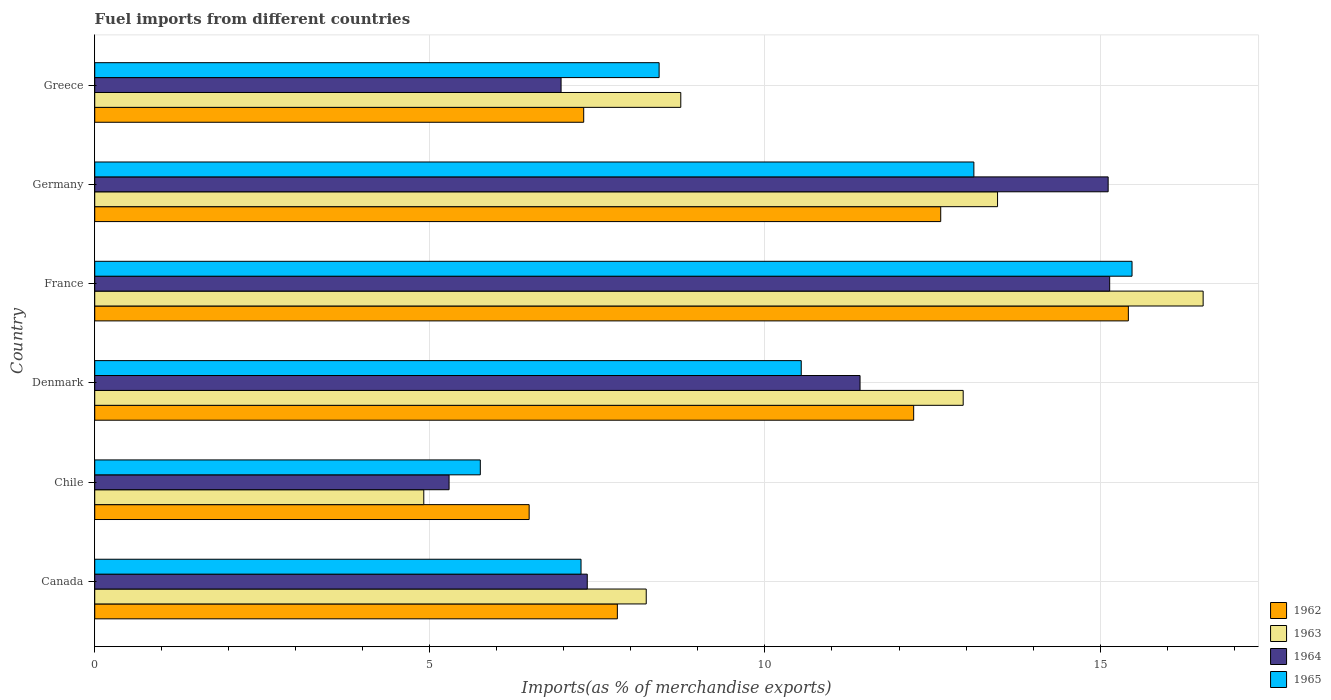How many different coloured bars are there?
Ensure brevity in your answer.  4. How many groups of bars are there?
Offer a terse response. 6. Are the number of bars per tick equal to the number of legend labels?
Your answer should be very brief. Yes. How many bars are there on the 5th tick from the bottom?
Provide a succinct answer. 4. What is the percentage of imports to different countries in 1963 in Denmark?
Ensure brevity in your answer.  12.96. Across all countries, what is the maximum percentage of imports to different countries in 1964?
Provide a succinct answer. 15.14. Across all countries, what is the minimum percentage of imports to different countries in 1963?
Your response must be concise. 4.91. In which country was the percentage of imports to different countries in 1964 maximum?
Provide a succinct answer. France. What is the total percentage of imports to different countries in 1962 in the graph?
Keep it short and to the point. 61.84. What is the difference between the percentage of imports to different countries in 1965 in Chile and that in Germany?
Your answer should be very brief. -7.36. What is the difference between the percentage of imports to different countries in 1964 in Greece and the percentage of imports to different countries in 1965 in France?
Keep it short and to the point. -8.52. What is the average percentage of imports to different countries in 1962 per country?
Provide a short and direct response. 10.31. What is the difference between the percentage of imports to different countries in 1965 and percentage of imports to different countries in 1962 in France?
Provide a succinct answer. 0.05. In how many countries, is the percentage of imports to different countries in 1962 greater than 3 %?
Make the answer very short. 6. What is the ratio of the percentage of imports to different countries in 1965 in Canada to that in Greece?
Ensure brevity in your answer.  0.86. Is the difference between the percentage of imports to different countries in 1965 in Chile and France greater than the difference between the percentage of imports to different countries in 1962 in Chile and France?
Provide a succinct answer. No. What is the difference between the highest and the second highest percentage of imports to different countries in 1962?
Keep it short and to the point. 2.8. What is the difference between the highest and the lowest percentage of imports to different countries in 1965?
Offer a terse response. 9.72. In how many countries, is the percentage of imports to different countries in 1963 greater than the average percentage of imports to different countries in 1963 taken over all countries?
Your answer should be very brief. 3. Is the sum of the percentage of imports to different countries in 1964 in Denmark and Greece greater than the maximum percentage of imports to different countries in 1962 across all countries?
Provide a succinct answer. Yes. Is it the case that in every country, the sum of the percentage of imports to different countries in 1962 and percentage of imports to different countries in 1964 is greater than the sum of percentage of imports to different countries in 1965 and percentage of imports to different countries in 1963?
Your answer should be compact. No. How many countries are there in the graph?
Give a very brief answer. 6. What is the difference between two consecutive major ticks on the X-axis?
Offer a terse response. 5. Are the values on the major ticks of X-axis written in scientific E-notation?
Provide a short and direct response. No. Does the graph contain grids?
Ensure brevity in your answer.  Yes. What is the title of the graph?
Ensure brevity in your answer.  Fuel imports from different countries. Does "1970" appear as one of the legend labels in the graph?
Provide a succinct answer. No. What is the label or title of the X-axis?
Give a very brief answer. Imports(as % of merchandise exports). What is the label or title of the Y-axis?
Your answer should be compact. Country. What is the Imports(as % of merchandise exports) in 1962 in Canada?
Provide a succinct answer. 7.8. What is the Imports(as % of merchandise exports) in 1963 in Canada?
Offer a terse response. 8.23. What is the Imports(as % of merchandise exports) of 1964 in Canada?
Your response must be concise. 7.35. What is the Imports(as % of merchandise exports) of 1965 in Canada?
Offer a terse response. 7.26. What is the Imports(as % of merchandise exports) of 1962 in Chile?
Keep it short and to the point. 6.48. What is the Imports(as % of merchandise exports) in 1963 in Chile?
Make the answer very short. 4.91. What is the Imports(as % of merchandise exports) in 1964 in Chile?
Provide a short and direct response. 5.29. What is the Imports(as % of merchandise exports) in 1965 in Chile?
Your answer should be very brief. 5.75. What is the Imports(as % of merchandise exports) of 1962 in Denmark?
Give a very brief answer. 12.22. What is the Imports(as % of merchandise exports) of 1963 in Denmark?
Provide a short and direct response. 12.96. What is the Imports(as % of merchandise exports) in 1964 in Denmark?
Your response must be concise. 11.42. What is the Imports(as % of merchandise exports) in 1965 in Denmark?
Keep it short and to the point. 10.54. What is the Imports(as % of merchandise exports) in 1962 in France?
Your answer should be compact. 15.42. What is the Imports(as % of merchandise exports) in 1963 in France?
Give a very brief answer. 16.54. What is the Imports(as % of merchandise exports) in 1964 in France?
Your answer should be compact. 15.14. What is the Imports(as % of merchandise exports) of 1965 in France?
Ensure brevity in your answer.  15.48. What is the Imports(as % of merchandise exports) of 1962 in Germany?
Your answer should be compact. 12.62. What is the Imports(as % of merchandise exports) of 1963 in Germany?
Offer a very short reply. 13.47. What is the Imports(as % of merchandise exports) in 1964 in Germany?
Make the answer very short. 15.12. What is the Imports(as % of merchandise exports) of 1965 in Germany?
Provide a succinct answer. 13.12. What is the Imports(as % of merchandise exports) of 1962 in Greece?
Your response must be concise. 7.3. What is the Imports(as % of merchandise exports) in 1963 in Greece?
Provide a short and direct response. 8.74. What is the Imports(as % of merchandise exports) of 1964 in Greece?
Offer a terse response. 6.96. What is the Imports(as % of merchandise exports) of 1965 in Greece?
Provide a short and direct response. 8.42. Across all countries, what is the maximum Imports(as % of merchandise exports) of 1962?
Provide a succinct answer. 15.42. Across all countries, what is the maximum Imports(as % of merchandise exports) in 1963?
Offer a very short reply. 16.54. Across all countries, what is the maximum Imports(as % of merchandise exports) of 1964?
Offer a very short reply. 15.14. Across all countries, what is the maximum Imports(as % of merchandise exports) of 1965?
Ensure brevity in your answer.  15.48. Across all countries, what is the minimum Imports(as % of merchandise exports) in 1962?
Offer a terse response. 6.48. Across all countries, what is the minimum Imports(as % of merchandise exports) in 1963?
Your answer should be very brief. 4.91. Across all countries, what is the minimum Imports(as % of merchandise exports) in 1964?
Provide a succinct answer. 5.29. Across all countries, what is the minimum Imports(as % of merchandise exports) of 1965?
Ensure brevity in your answer.  5.75. What is the total Imports(as % of merchandise exports) in 1962 in the graph?
Your answer should be very brief. 61.84. What is the total Imports(as % of merchandise exports) in 1963 in the graph?
Give a very brief answer. 64.85. What is the total Imports(as % of merchandise exports) in 1964 in the graph?
Keep it short and to the point. 61.28. What is the total Imports(as % of merchandise exports) of 1965 in the graph?
Your answer should be compact. 60.57. What is the difference between the Imports(as % of merchandise exports) of 1962 in Canada and that in Chile?
Ensure brevity in your answer.  1.32. What is the difference between the Imports(as % of merchandise exports) in 1963 in Canada and that in Chile?
Your response must be concise. 3.32. What is the difference between the Imports(as % of merchandise exports) in 1964 in Canada and that in Chile?
Offer a very short reply. 2.06. What is the difference between the Imports(as % of merchandise exports) of 1965 in Canada and that in Chile?
Give a very brief answer. 1.5. What is the difference between the Imports(as % of merchandise exports) of 1962 in Canada and that in Denmark?
Your answer should be very brief. -4.42. What is the difference between the Imports(as % of merchandise exports) in 1963 in Canada and that in Denmark?
Offer a terse response. -4.73. What is the difference between the Imports(as % of merchandise exports) in 1964 in Canada and that in Denmark?
Offer a terse response. -4.07. What is the difference between the Imports(as % of merchandise exports) of 1965 in Canada and that in Denmark?
Provide a short and direct response. -3.29. What is the difference between the Imports(as % of merchandise exports) in 1962 in Canada and that in France?
Offer a very short reply. -7.62. What is the difference between the Imports(as % of merchandise exports) of 1963 in Canada and that in France?
Give a very brief answer. -8.31. What is the difference between the Imports(as % of merchandise exports) of 1964 in Canada and that in France?
Make the answer very short. -7.79. What is the difference between the Imports(as % of merchandise exports) of 1965 in Canada and that in France?
Your answer should be very brief. -8.22. What is the difference between the Imports(as % of merchandise exports) of 1962 in Canada and that in Germany?
Make the answer very short. -4.82. What is the difference between the Imports(as % of merchandise exports) in 1963 in Canada and that in Germany?
Provide a succinct answer. -5.24. What is the difference between the Imports(as % of merchandise exports) in 1964 in Canada and that in Germany?
Offer a very short reply. -7.77. What is the difference between the Imports(as % of merchandise exports) in 1965 in Canada and that in Germany?
Offer a very short reply. -5.86. What is the difference between the Imports(as % of merchandise exports) of 1962 in Canada and that in Greece?
Offer a very short reply. 0.5. What is the difference between the Imports(as % of merchandise exports) of 1963 in Canada and that in Greece?
Give a very brief answer. -0.52. What is the difference between the Imports(as % of merchandise exports) in 1964 in Canada and that in Greece?
Give a very brief answer. 0.39. What is the difference between the Imports(as % of merchandise exports) in 1965 in Canada and that in Greece?
Offer a very short reply. -1.17. What is the difference between the Imports(as % of merchandise exports) in 1962 in Chile and that in Denmark?
Provide a succinct answer. -5.74. What is the difference between the Imports(as % of merchandise exports) in 1963 in Chile and that in Denmark?
Ensure brevity in your answer.  -8.05. What is the difference between the Imports(as % of merchandise exports) of 1964 in Chile and that in Denmark?
Offer a very short reply. -6.13. What is the difference between the Imports(as % of merchandise exports) of 1965 in Chile and that in Denmark?
Your answer should be very brief. -4.79. What is the difference between the Imports(as % of merchandise exports) of 1962 in Chile and that in France?
Provide a succinct answer. -8.94. What is the difference between the Imports(as % of merchandise exports) in 1963 in Chile and that in France?
Keep it short and to the point. -11.63. What is the difference between the Imports(as % of merchandise exports) in 1964 in Chile and that in France?
Ensure brevity in your answer.  -9.86. What is the difference between the Imports(as % of merchandise exports) in 1965 in Chile and that in France?
Keep it short and to the point. -9.72. What is the difference between the Imports(as % of merchandise exports) of 1962 in Chile and that in Germany?
Your response must be concise. -6.14. What is the difference between the Imports(as % of merchandise exports) of 1963 in Chile and that in Germany?
Make the answer very short. -8.56. What is the difference between the Imports(as % of merchandise exports) of 1964 in Chile and that in Germany?
Keep it short and to the point. -9.83. What is the difference between the Imports(as % of merchandise exports) in 1965 in Chile and that in Germany?
Offer a terse response. -7.36. What is the difference between the Imports(as % of merchandise exports) in 1962 in Chile and that in Greece?
Give a very brief answer. -0.81. What is the difference between the Imports(as % of merchandise exports) of 1963 in Chile and that in Greece?
Your answer should be very brief. -3.83. What is the difference between the Imports(as % of merchandise exports) of 1964 in Chile and that in Greece?
Give a very brief answer. -1.67. What is the difference between the Imports(as % of merchandise exports) of 1965 in Chile and that in Greece?
Your response must be concise. -2.67. What is the difference between the Imports(as % of merchandise exports) of 1962 in Denmark and that in France?
Offer a very short reply. -3.2. What is the difference between the Imports(as % of merchandise exports) in 1963 in Denmark and that in France?
Your response must be concise. -3.58. What is the difference between the Imports(as % of merchandise exports) in 1964 in Denmark and that in France?
Your response must be concise. -3.72. What is the difference between the Imports(as % of merchandise exports) of 1965 in Denmark and that in France?
Your answer should be compact. -4.94. What is the difference between the Imports(as % of merchandise exports) of 1962 in Denmark and that in Germany?
Your answer should be compact. -0.4. What is the difference between the Imports(as % of merchandise exports) in 1963 in Denmark and that in Germany?
Offer a terse response. -0.51. What is the difference between the Imports(as % of merchandise exports) in 1964 in Denmark and that in Germany?
Offer a very short reply. -3.7. What is the difference between the Imports(as % of merchandise exports) in 1965 in Denmark and that in Germany?
Offer a terse response. -2.58. What is the difference between the Imports(as % of merchandise exports) in 1962 in Denmark and that in Greece?
Give a very brief answer. 4.92. What is the difference between the Imports(as % of merchandise exports) of 1963 in Denmark and that in Greece?
Ensure brevity in your answer.  4.21. What is the difference between the Imports(as % of merchandise exports) in 1964 in Denmark and that in Greece?
Provide a succinct answer. 4.46. What is the difference between the Imports(as % of merchandise exports) in 1965 in Denmark and that in Greece?
Make the answer very short. 2.12. What is the difference between the Imports(as % of merchandise exports) in 1962 in France and that in Germany?
Your answer should be compact. 2.8. What is the difference between the Imports(as % of merchandise exports) of 1963 in France and that in Germany?
Your answer should be very brief. 3.07. What is the difference between the Imports(as % of merchandise exports) of 1964 in France and that in Germany?
Your answer should be compact. 0.02. What is the difference between the Imports(as % of merchandise exports) of 1965 in France and that in Germany?
Ensure brevity in your answer.  2.36. What is the difference between the Imports(as % of merchandise exports) of 1962 in France and that in Greece?
Give a very brief answer. 8.13. What is the difference between the Imports(as % of merchandise exports) in 1963 in France and that in Greece?
Offer a very short reply. 7.79. What is the difference between the Imports(as % of merchandise exports) in 1964 in France and that in Greece?
Make the answer very short. 8.19. What is the difference between the Imports(as % of merchandise exports) of 1965 in France and that in Greece?
Provide a short and direct response. 7.06. What is the difference between the Imports(as % of merchandise exports) of 1962 in Germany and that in Greece?
Make the answer very short. 5.33. What is the difference between the Imports(as % of merchandise exports) in 1963 in Germany and that in Greece?
Give a very brief answer. 4.73. What is the difference between the Imports(as % of merchandise exports) in 1964 in Germany and that in Greece?
Give a very brief answer. 8.16. What is the difference between the Imports(as % of merchandise exports) of 1965 in Germany and that in Greece?
Your answer should be compact. 4.7. What is the difference between the Imports(as % of merchandise exports) of 1962 in Canada and the Imports(as % of merchandise exports) of 1963 in Chile?
Give a very brief answer. 2.89. What is the difference between the Imports(as % of merchandise exports) of 1962 in Canada and the Imports(as % of merchandise exports) of 1964 in Chile?
Make the answer very short. 2.51. What is the difference between the Imports(as % of merchandise exports) in 1962 in Canada and the Imports(as % of merchandise exports) in 1965 in Chile?
Your answer should be compact. 2.04. What is the difference between the Imports(as % of merchandise exports) of 1963 in Canada and the Imports(as % of merchandise exports) of 1964 in Chile?
Give a very brief answer. 2.94. What is the difference between the Imports(as % of merchandise exports) of 1963 in Canada and the Imports(as % of merchandise exports) of 1965 in Chile?
Give a very brief answer. 2.48. What is the difference between the Imports(as % of merchandise exports) in 1964 in Canada and the Imports(as % of merchandise exports) in 1965 in Chile?
Your response must be concise. 1.6. What is the difference between the Imports(as % of merchandise exports) of 1962 in Canada and the Imports(as % of merchandise exports) of 1963 in Denmark?
Provide a short and direct response. -5.16. What is the difference between the Imports(as % of merchandise exports) in 1962 in Canada and the Imports(as % of merchandise exports) in 1964 in Denmark?
Make the answer very short. -3.62. What is the difference between the Imports(as % of merchandise exports) in 1962 in Canada and the Imports(as % of merchandise exports) in 1965 in Denmark?
Make the answer very short. -2.74. What is the difference between the Imports(as % of merchandise exports) of 1963 in Canada and the Imports(as % of merchandise exports) of 1964 in Denmark?
Offer a terse response. -3.19. What is the difference between the Imports(as % of merchandise exports) in 1963 in Canada and the Imports(as % of merchandise exports) in 1965 in Denmark?
Your response must be concise. -2.31. What is the difference between the Imports(as % of merchandise exports) of 1964 in Canada and the Imports(as % of merchandise exports) of 1965 in Denmark?
Ensure brevity in your answer.  -3.19. What is the difference between the Imports(as % of merchandise exports) of 1962 in Canada and the Imports(as % of merchandise exports) of 1963 in France?
Give a very brief answer. -8.74. What is the difference between the Imports(as % of merchandise exports) of 1962 in Canada and the Imports(as % of merchandise exports) of 1964 in France?
Give a very brief answer. -7.35. What is the difference between the Imports(as % of merchandise exports) in 1962 in Canada and the Imports(as % of merchandise exports) in 1965 in France?
Your answer should be very brief. -7.68. What is the difference between the Imports(as % of merchandise exports) in 1963 in Canada and the Imports(as % of merchandise exports) in 1964 in France?
Keep it short and to the point. -6.91. What is the difference between the Imports(as % of merchandise exports) of 1963 in Canada and the Imports(as % of merchandise exports) of 1965 in France?
Provide a succinct answer. -7.25. What is the difference between the Imports(as % of merchandise exports) of 1964 in Canada and the Imports(as % of merchandise exports) of 1965 in France?
Provide a succinct answer. -8.13. What is the difference between the Imports(as % of merchandise exports) in 1962 in Canada and the Imports(as % of merchandise exports) in 1963 in Germany?
Offer a terse response. -5.67. What is the difference between the Imports(as % of merchandise exports) in 1962 in Canada and the Imports(as % of merchandise exports) in 1964 in Germany?
Your response must be concise. -7.32. What is the difference between the Imports(as % of merchandise exports) of 1962 in Canada and the Imports(as % of merchandise exports) of 1965 in Germany?
Your response must be concise. -5.32. What is the difference between the Imports(as % of merchandise exports) of 1963 in Canada and the Imports(as % of merchandise exports) of 1964 in Germany?
Your response must be concise. -6.89. What is the difference between the Imports(as % of merchandise exports) in 1963 in Canada and the Imports(as % of merchandise exports) in 1965 in Germany?
Your response must be concise. -4.89. What is the difference between the Imports(as % of merchandise exports) in 1964 in Canada and the Imports(as % of merchandise exports) in 1965 in Germany?
Your answer should be very brief. -5.77. What is the difference between the Imports(as % of merchandise exports) in 1962 in Canada and the Imports(as % of merchandise exports) in 1963 in Greece?
Keep it short and to the point. -0.95. What is the difference between the Imports(as % of merchandise exports) of 1962 in Canada and the Imports(as % of merchandise exports) of 1964 in Greece?
Provide a short and direct response. 0.84. What is the difference between the Imports(as % of merchandise exports) of 1962 in Canada and the Imports(as % of merchandise exports) of 1965 in Greece?
Your answer should be very brief. -0.62. What is the difference between the Imports(as % of merchandise exports) in 1963 in Canada and the Imports(as % of merchandise exports) in 1964 in Greece?
Keep it short and to the point. 1.27. What is the difference between the Imports(as % of merchandise exports) of 1963 in Canada and the Imports(as % of merchandise exports) of 1965 in Greece?
Provide a succinct answer. -0.19. What is the difference between the Imports(as % of merchandise exports) in 1964 in Canada and the Imports(as % of merchandise exports) in 1965 in Greece?
Provide a short and direct response. -1.07. What is the difference between the Imports(as % of merchandise exports) of 1962 in Chile and the Imports(as % of merchandise exports) of 1963 in Denmark?
Your answer should be very brief. -6.48. What is the difference between the Imports(as % of merchandise exports) in 1962 in Chile and the Imports(as % of merchandise exports) in 1964 in Denmark?
Offer a terse response. -4.94. What is the difference between the Imports(as % of merchandise exports) of 1962 in Chile and the Imports(as % of merchandise exports) of 1965 in Denmark?
Your response must be concise. -4.06. What is the difference between the Imports(as % of merchandise exports) in 1963 in Chile and the Imports(as % of merchandise exports) in 1964 in Denmark?
Your answer should be compact. -6.51. What is the difference between the Imports(as % of merchandise exports) in 1963 in Chile and the Imports(as % of merchandise exports) in 1965 in Denmark?
Your answer should be very brief. -5.63. What is the difference between the Imports(as % of merchandise exports) of 1964 in Chile and the Imports(as % of merchandise exports) of 1965 in Denmark?
Offer a very short reply. -5.25. What is the difference between the Imports(as % of merchandise exports) in 1962 in Chile and the Imports(as % of merchandise exports) in 1963 in France?
Keep it short and to the point. -10.06. What is the difference between the Imports(as % of merchandise exports) in 1962 in Chile and the Imports(as % of merchandise exports) in 1964 in France?
Your response must be concise. -8.66. What is the difference between the Imports(as % of merchandise exports) of 1962 in Chile and the Imports(as % of merchandise exports) of 1965 in France?
Your answer should be very brief. -9. What is the difference between the Imports(as % of merchandise exports) of 1963 in Chile and the Imports(as % of merchandise exports) of 1964 in France?
Ensure brevity in your answer.  -10.23. What is the difference between the Imports(as % of merchandise exports) in 1963 in Chile and the Imports(as % of merchandise exports) in 1965 in France?
Give a very brief answer. -10.57. What is the difference between the Imports(as % of merchandise exports) in 1964 in Chile and the Imports(as % of merchandise exports) in 1965 in France?
Your answer should be compact. -10.19. What is the difference between the Imports(as % of merchandise exports) of 1962 in Chile and the Imports(as % of merchandise exports) of 1963 in Germany?
Offer a terse response. -6.99. What is the difference between the Imports(as % of merchandise exports) in 1962 in Chile and the Imports(as % of merchandise exports) in 1964 in Germany?
Offer a very short reply. -8.64. What is the difference between the Imports(as % of merchandise exports) of 1962 in Chile and the Imports(as % of merchandise exports) of 1965 in Germany?
Provide a short and direct response. -6.64. What is the difference between the Imports(as % of merchandise exports) in 1963 in Chile and the Imports(as % of merchandise exports) in 1964 in Germany?
Your answer should be compact. -10.21. What is the difference between the Imports(as % of merchandise exports) in 1963 in Chile and the Imports(as % of merchandise exports) in 1965 in Germany?
Ensure brevity in your answer.  -8.21. What is the difference between the Imports(as % of merchandise exports) in 1964 in Chile and the Imports(as % of merchandise exports) in 1965 in Germany?
Your response must be concise. -7.83. What is the difference between the Imports(as % of merchandise exports) in 1962 in Chile and the Imports(as % of merchandise exports) in 1963 in Greece?
Give a very brief answer. -2.26. What is the difference between the Imports(as % of merchandise exports) of 1962 in Chile and the Imports(as % of merchandise exports) of 1964 in Greece?
Keep it short and to the point. -0.48. What is the difference between the Imports(as % of merchandise exports) of 1962 in Chile and the Imports(as % of merchandise exports) of 1965 in Greece?
Keep it short and to the point. -1.94. What is the difference between the Imports(as % of merchandise exports) of 1963 in Chile and the Imports(as % of merchandise exports) of 1964 in Greece?
Your answer should be compact. -2.05. What is the difference between the Imports(as % of merchandise exports) in 1963 in Chile and the Imports(as % of merchandise exports) in 1965 in Greece?
Provide a succinct answer. -3.51. What is the difference between the Imports(as % of merchandise exports) of 1964 in Chile and the Imports(as % of merchandise exports) of 1965 in Greece?
Your answer should be compact. -3.13. What is the difference between the Imports(as % of merchandise exports) of 1962 in Denmark and the Imports(as % of merchandise exports) of 1963 in France?
Your answer should be very brief. -4.32. What is the difference between the Imports(as % of merchandise exports) in 1962 in Denmark and the Imports(as % of merchandise exports) in 1964 in France?
Make the answer very short. -2.92. What is the difference between the Imports(as % of merchandise exports) in 1962 in Denmark and the Imports(as % of merchandise exports) in 1965 in France?
Your response must be concise. -3.26. What is the difference between the Imports(as % of merchandise exports) of 1963 in Denmark and the Imports(as % of merchandise exports) of 1964 in France?
Provide a short and direct response. -2.19. What is the difference between the Imports(as % of merchandise exports) of 1963 in Denmark and the Imports(as % of merchandise exports) of 1965 in France?
Your response must be concise. -2.52. What is the difference between the Imports(as % of merchandise exports) in 1964 in Denmark and the Imports(as % of merchandise exports) in 1965 in France?
Keep it short and to the point. -4.06. What is the difference between the Imports(as % of merchandise exports) of 1962 in Denmark and the Imports(as % of merchandise exports) of 1963 in Germany?
Your answer should be compact. -1.25. What is the difference between the Imports(as % of merchandise exports) of 1962 in Denmark and the Imports(as % of merchandise exports) of 1964 in Germany?
Give a very brief answer. -2.9. What is the difference between the Imports(as % of merchandise exports) of 1962 in Denmark and the Imports(as % of merchandise exports) of 1965 in Germany?
Provide a succinct answer. -0.9. What is the difference between the Imports(as % of merchandise exports) in 1963 in Denmark and the Imports(as % of merchandise exports) in 1964 in Germany?
Give a very brief answer. -2.16. What is the difference between the Imports(as % of merchandise exports) of 1963 in Denmark and the Imports(as % of merchandise exports) of 1965 in Germany?
Offer a terse response. -0.16. What is the difference between the Imports(as % of merchandise exports) of 1964 in Denmark and the Imports(as % of merchandise exports) of 1965 in Germany?
Offer a very short reply. -1.7. What is the difference between the Imports(as % of merchandise exports) of 1962 in Denmark and the Imports(as % of merchandise exports) of 1963 in Greece?
Make the answer very short. 3.48. What is the difference between the Imports(as % of merchandise exports) of 1962 in Denmark and the Imports(as % of merchandise exports) of 1964 in Greece?
Your answer should be very brief. 5.26. What is the difference between the Imports(as % of merchandise exports) in 1962 in Denmark and the Imports(as % of merchandise exports) in 1965 in Greece?
Your answer should be compact. 3.8. What is the difference between the Imports(as % of merchandise exports) in 1963 in Denmark and the Imports(as % of merchandise exports) in 1964 in Greece?
Make the answer very short. 6. What is the difference between the Imports(as % of merchandise exports) of 1963 in Denmark and the Imports(as % of merchandise exports) of 1965 in Greece?
Ensure brevity in your answer.  4.54. What is the difference between the Imports(as % of merchandise exports) in 1964 in Denmark and the Imports(as % of merchandise exports) in 1965 in Greece?
Your response must be concise. 3. What is the difference between the Imports(as % of merchandise exports) in 1962 in France and the Imports(as % of merchandise exports) in 1963 in Germany?
Ensure brevity in your answer.  1.95. What is the difference between the Imports(as % of merchandise exports) of 1962 in France and the Imports(as % of merchandise exports) of 1964 in Germany?
Keep it short and to the point. 0.3. What is the difference between the Imports(as % of merchandise exports) of 1962 in France and the Imports(as % of merchandise exports) of 1965 in Germany?
Provide a succinct answer. 2.31. What is the difference between the Imports(as % of merchandise exports) in 1963 in France and the Imports(as % of merchandise exports) in 1964 in Germany?
Your answer should be compact. 1.42. What is the difference between the Imports(as % of merchandise exports) in 1963 in France and the Imports(as % of merchandise exports) in 1965 in Germany?
Offer a terse response. 3.42. What is the difference between the Imports(as % of merchandise exports) of 1964 in France and the Imports(as % of merchandise exports) of 1965 in Germany?
Make the answer very short. 2.03. What is the difference between the Imports(as % of merchandise exports) in 1962 in France and the Imports(as % of merchandise exports) in 1963 in Greece?
Offer a very short reply. 6.68. What is the difference between the Imports(as % of merchandise exports) of 1962 in France and the Imports(as % of merchandise exports) of 1964 in Greece?
Provide a short and direct response. 8.46. What is the difference between the Imports(as % of merchandise exports) of 1962 in France and the Imports(as % of merchandise exports) of 1965 in Greece?
Make the answer very short. 7. What is the difference between the Imports(as % of merchandise exports) in 1963 in France and the Imports(as % of merchandise exports) in 1964 in Greece?
Offer a very short reply. 9.58. What is the difference between the Imports(as % of merchandise exports) in 1963 in France and the Imports(as % of merchandise exports) in 1965 in Greece?
Give a very brief answer. 8.12. What is the difference between the Imports(as % of merchandise exports) of 1964 in France and the Imports(as % of merchandise exports) of 1965 in Greece?
Ensure brevity in your answer.  6.72. What is the difference between the Imports(as % of merchandise exports) in 1962 in Germany and the Imports(as % of merchandise exports) in 1963 in Greece?
Give a very brief answer. 3.88. What is the difference between the Imports(as % of merchandise exports) of 1962 in Germany and the Imports(as % of merchandise exports) of 1964 in Greece?
Provide a short and direct response. 5.66. What is the difference between the Imports(as % of merchandise exports) of 1962 in Germany and the Imports(as % of merchandise exports) of 1965 in Greece?
Your answer should be very brief. 4.2. What is the difference between the Imports(as % of merchandise exports) in 1963 in Germany and the Imports(as % of merchandise exports) in 1964 in Greece?
Your answer should be compact. 6.51. What is the difference between the Imports(as % of merchandise exports) of 1963 in Germany and the Imports(as % of merchandise exports) of 1965 in Greece?
Offer a terse response. 5.05. What is the difference between the Imports(as % of merchandise exports) in 1964 in Germany and the Imports(as % of merchandise exports) in 1965 in Greece?
Provide a short and direct response. 6.7. What is the average Imports(as % of merchandise exports) in 1962 per country?
Ensure brevity in your answer.  10.31. What is the average Imports(as % of merchandise exports) in 1963 per country?
Your answer should be compact. 10.81. What is the average Imports(as % of merchandise exports) in 1964 per country?
Provide a succinct answer. 10.21. What is the average Imports(as % of merchandise exports) in 1965 per country?
Provide a short and direct response. 10.09. What is the difference between the Imports(as % of merchandise exports) of 1962 and Imports(as % of merchandise exports) of 1963 in Canada?
Offer a very short reply. -0.43. What is the difference between the Imports(as % of merchandise exports) of 1962 and Imports(as % of merchandise exports) of 1964 in Canada?
Your response must be concise. 0.45. What is the difference between the Imports(as % of merchandise exports) in 1962 and Imports(as % of merchandise exports) in 1965 in Canada?
Provide a short and direct response. 0.54. What is the difference between the Imports(as % of merchandise exports) in 1963 and Imports(as % of merchandise exports) in 1964 in Canada?
Offer a very short reply. 0.88. What is the difference between the Imports(as % of merchandise exports) in 1963 and Imports(as % of merchandise exports) in 1965 in Canada?
Your answer should be compact. 0.97. What is the difference between the Imports(as % of merchandise exports) of 1964 and Imports(as % of merchandise exports) of 1965 in Canada?
Make the answer very short. 0.09. What is the difference between the Imports(as % of merchandise exports) in 1962 and Imports(as % of merchandise exports) in 1963 in Chile?
Your response must be concise. 1.57. What is the difference between the Imports(as % of merchandise exports) in 1962 and Imports(as % of merchandise exports) in 1964 in Chile?
Make the answer very short. 1.19. What is the difference between the Imports(as % of merchandise exports) of 1962 and Imports(as % of merchandise exports) of 1965 in Chile?
Provide a succinct answer. 0.73. What is the difference between the Imports(as % of merchandise exports) in 1963 and Imports(as % of merchandise exports) in 1964 in Chile?
Your answer should be very brief. -0.38. What is the difference between the Imports(as % of merchandise exports) of 1963 and Imports(as % of merchandise exports) of 1965 in Chile?
Your answer should be compact. -0.84. What is the difference between the Imports(as % of merchandise exports) of 1964 and Imports(as % of merchandise exports) of 1965 in Chile?
Give a very brief answer. -0.47. What is the difference between the Imports(as % of merchandise exports) in 1962 and Imports(as % of merchandise exports) in 1963 in Denmark?
Offer a terse response. -0.74. What is the difference between the Imports(as % of merchandise exports) in 1962 and Imports(as % of merchandise exports) in 1964 in Denmark?
Keep it short and to the point. 0.8. What is the difference between the Imports(as % of merchandise exports) in 1962 and Imports(as % of merchandise exports) in 1965 in Denmark?
Provide a succinct answer. 1.68. What is the difference between the Imports(as % of merchandise exports) in 1963 and Imports(as % of merchandise exports) in 1964 in Denmark?
Make the answer very short. 1.54. What is the difference between the Imports(as % of merchandise exports) in 1963 and Imports(as % of merchandise exports) in 1965 in Denmark?
Provide a succinct answer. 2.42. What is the difference between the Imports(as % of merchandise exports) of 1964 and Imports(as % of merchandise exports) of 1965 in Denmark?
Your answer should be compact. 0.88. What is the difference between the Imports(as % of merchandise exports) in 1962 and Imports(as % of merchandise exports) in 1963 in France?
Give a very brief answer. -1.12. What is the difference between the Imports(as % of merchandise exports) in 1962 and Imports(as % of merchandise exports) in 1964 in France?
Keep it short and to the point. 0.28. What is the difference between the Imports(as % of merchandise exports) of 1962 and Imports(as % of merchandise exports) of 1965 in France?
Your answer should be compact. -0.05. What is the difference between the Imports(as % of merchandise exports) of 1963 and Imports(as % of merchandise exports) of 1964 in France?
Provide a short and direct response. 1.39. What is the difference between the Imports(as % of merchandise exports) of 1963 and Imports(as % of merchandise exports) of 1965 in France?
Ensure brevity in your answer.  1.06. What is the difference between the Imports(as % of merchandise exports) in 1964 and Imports(as % of merchandise exports) in 1965 in France?
Keep it short and to the point. -0.33. What is the difference between the Imports(as % of merchandise exports) in 1962 and Imports(as % of merchandise exports) in 1963 in Germany?
Offer a terse response. -0.85. What is the difference between the Imports(as % of merchandise exports) of 1962 and Imports(as % of merchandise exports) of 1964 in Germany?
Make the answer very short. -2.5. What is the difference between the Imports(as % of merchandise exports) in 1962 and Imports(as % of merchandise exports) in 1965 in Germany?
Your response must be concise. -0.49. What is the difference between the Imports(as % of merchandise exports) of 1963 and Imports(as % of merchandise exports) of 1964 in Germany?
Offer a terse response. -1.65. What is the difference between the Imports(as % of merchandise exports) of 1963 and Imports(as % of merchandise exports) of 1965 in Germany?
Give a very brief answer. 0.35. What is the difference between the Imports(as % of merchandise exports) of 1964 and Imports(as % of merchandise exports) of 1965 in Germany?
Keep it short and to the point. 2. What is the difference between the Imports(as % of merchandise exports) of 1962 and Imports(as % of merchandise exports) of 1963 in Greece?
Your response must be concise. -1.45. What is the difference between the Imports(as % of merchandise exports) of 1962 and Imports(as % of merchandise exports) of 1964 in Greece?
Your response must be concise. 0.34. What is the difference between the Imports(as % of merchandise exports) of 1962 and Imports(as % of merchandise exports) of 1965 in Greece?
Give a very brief answer. -1.13. What is the difference between the Imports(as % of merchandise exports) of 1963 and Imports(as % of merchandise exports) of 1964 in Greece?
Your response must be concise. 1.79. What is the difference between the Imports(as % of merchandise exports) in 1963 and Imports(as % of merchandise exports) in 1965 in Greece?
Your answer should be compact. 0.32. What is the difference between the Imports(as % of merchandise exports) in 1964 and Imports(as % of merchandise exports) in 1965 in Greece?
Offer a very short reply. -1.46. What is the ratio of the Imports(as % of merchandise exports) in 1962 in Canada to that in Chile?
Your response must be concise. 1.2. What is the ratio of the Imports(as % of merchandise exports) in 1963 in Canada to that in Chile?
Make the answer very short. 1.68. What is the ratio of the Imports(as % of merchandise exports) of 1964 in Canada to that in Chile?
Your response must be concise. 1.39. What is the ratio of the Imports(as % of merchandise exports) in 1965 in Canada to that in Chile?
Provide a succinct answer. 1.26. What is the ratio of the Imports(as % of merchandise exports) in 1962 in Canada to that in Denmark?
Offer a very short reply. 0.64. What is the ratio of the Imports(as % of merchandise exports) in 1963 in Canada to that in Denmark?
Your answer should be very brief. 0.64. What is the ratio of the Imports(as % of merchandise exports) in 1964 in Canada to that in Denmark?
Offer a terse response. 0.64. What is the ratio of the Imports(as % of merchandise exports) in 1965 in Canada to that in Denmark?
Your answer should be very brief. 0.69. What is the ratio of the Imports(as % of merchandise exports) in 1962 in Canada to that in France?
Give a very brief answer. 0.51. What is the ratio of the Imports(as % of merchandise exports) of 1963 in Canada to that in France?
Give a very brief answer. 0.5. What is the ratio of the Imports(as % of merchandise exports) in 1964 in Canada to that in France?
Offer a terse response. 0.49. What is the ratio of the Imports(as % of merchandise exports) in 1965 in Canada to that in France?
Offer a very short reply. 0.47. What is the ratio of the Imports(as % of merchandise exports) of 1962 in Canada to that in Germany?
Your answer should be very brief. 0.62. What is the ratio of the Imports(as % of merchandise exports) of 1963 in Canada to that in Germany?
Your response must be concise. 0.61. What is the ratio of the Imports(as % of merchandise exports) in 1964 in Canada to that in Germany?
Offer a very short reply. 0.49. What is the ratio of the Imports(as % of merchandise exports) of 1965 in Canada to that in Germany?
Provide a short and direct response. 0.55. What is the ratio of the Imports(as % of merchandise exports) of 1962 in Canada to that in Greece?
Offer a very short reply. 1.07. What is the ratio of the Imports(as % of merchandise exports) of 1963 in Canada to that in Greece?
Provide a succinct answer. 0.94. What is the ratio of the Imports(as % of merchandise exports) in 1964 in Canada to that in Greece?
Offer a terse response. 1.06. What is the ratio of the Imports(as % of merchandise exports) of 1965 in Canada to that in Greece?
Your answer should be very brief. 0.86. What is the ratio of the Imports(as % of merchandise exports) in 1962 in Chile to that in Denmark?
Offer a terse response. 0.53. What is the ratio of the Imports(as % of merchandise exports) of 1963 in Chile to that in Denmark?
Your response must be concise. 0.38. What is the ratio of the Imports(as % of merchandise exports) in 1964 in Chile to that in Denmark?
Provide a succinct answer. 0.46. What is the ratio of the Imports(as % of merchandise exports) in 1965 in Chile to that in Denmark?
Keep it short and to the point. 0.55. What is the ratio of the Imports(as % of merchandise exports) of 1962 in Chile to that in France?
Your answer should be compact. 0.42. What is the ratio of the Imports(as % of merchandise exports) in 1963 in Chile to that in France?
Offer a very short reply. 0.3. What is the ratio of the Imports(as % of merchandise exports) of 1964 in Chile to that in France?
Your response must be concise. 0.35. What is the ratio of the Imports(as % of merchandise exports) of 1965 in Chile to that in France?
Make the answer very short. 0.37. What is the ratio of the Imports(as % of merchandise exports) in 1962 in Chile to that in Germany?
Your answer should be compact. 0.51. What is the ratio of the Imports(as % of merchandise exports) of 1963 in Chile to that in Germany?
Provide a succinct answer. 0.36. What is the ratio of the Imports(as % of merchandise exports) of 1964 in Chile to that in Germany?
Your answer should be very brief. 0.35. What is the ratio of the Imports(as % of merchandise exports) of 1965 in Chile to that in Germany?
Your response must be concise. 0.44. What is the ratio of the Imports(as % of merchandise exports) in 1962 in Chile to that in Greece?
Offer a very short reply. 0.89. What is the ratio of the Imports(as % of merchandise exports) in 1963 in Chile to that in Greece?
Your response must be concise. 0.56. What is the ratio of the Imports(as % of merchandise exports) of 1964 in Chile to that in Greece?
Your answer should be compact. 0.76. What is the ratio of the Imports(as % of merchandise exports) of 1965 in Chile to that in Greece?
Your response must be concise. 0.68. What is the ratio of the Imports(as % of merchandise exports) of 1962 in Denmark to that in France?
Keep it short and to the point. 0.79. What is the ratio of the Imports(as % of merchandise exports) of 1963 in Denmark to that in France?
Offer a terse response. 0.78. What is the ratio of the Imports(as % of merchandise exports) of 1964 in Denmark to that in France?
Make the answer very short. 0.75. What is the ratio of the Imports(as % of merchandise exports) of 1965 in Denmark to that in France?
Your answer should be compact. 0.68. What is the ratio of the Imports(as % of merchandise exports) in 1963 in Denmark to that in Germany?
Give a very brief answer. 0.96. What is the ratio of the Imports(as % of merchandise exports) of 1964 in Denmark to that in Germany?
Your answer should be compact. 0.76. What is the ratio of the Imports(as % of merchandise exports) in 1965 in Denmark to that in Germany?
Ensure brevity in your answer.  0.8. What is the ratio of the Imports(as % of merchandise exports) of 1962 in Denmark to that in Greece?
Provide a short and direct response. 1.67. What is the ratio of the Imports(as % of merchandise exports) of 1963 in Denmark to that in Greece?
Keep it short and to the point. 1.48. What is the ratio of the Imports(as % of merchandise exports) of 1964 in Denmark to that in Greece?
Your answer should be very brief. 1.64. What is the ratio of the Imports(as % of merchandise exports) of 1965 in Denmark to that in Greece?
Your answer should be very brief. 1.25. What is the ratio of the Imports(as % of merchandise exports) in 1962 in France to that in Germany?
Make the answer very short. 1.22. What is the ratio of the Imports(as % of merchandise exports) in 1963 in France to that in Germany?
Make the answer very short. 1.23. What is the ratio of the Imports(as % of merchandise exports) in 1964 in France to that in Germany?
Offer a very short reply. 1. What is the ratio of the Imports(as % of merchandise exports) of 1965 in France to that in Germany?
Your response must be concise. 1.18. What is the ratio of the Imports(as % of merchandise exports) in 1962 in France to that in Greece?
Your answer should be very brief. 2.11. What is the ratio of the Imports(as % of merchandise exports) of 1963 in France to that in Greece?
Provide a succinct answer. 1.89. What is the ratio of the Imports(as % of merchandise exports) of 1964 in France to that in Greece?
Provide a succinct answer. 2.18. What is the ratio of the Imports(as % of merchandise exports) in 1965 in France to that in Greece?
Keep it short and to the point. 1.84. What is the ratio of the Imports(as % of merchandise exports) in 1962 in Germany to that in Greece?
Offer a terse response. 1.73. What is the ratio of the Imports(as % of merchandise exports) of 1963 in Germany to that in Greece?
Provide a succinct answer. 1.54. What is the ratio of the Imports(as % of merchandise exports) in 1964 in Germany to that in Greece?
Provide a short and direct response. 2.17. What is the ratio of the Imports(as % of merchandise exports) of 1965 in Germany to that in Greece?
Your response must be concise. 1.56. What is the difference between the highest and the second highest Imports(as % of merchandise exports) of 1962?
Your answer should be very brief. 2.8. What is the difference between the highest and the second highest Imports(as % of merchandise exports) of 1963?
Offer a terse response. 3.07. What is the difference between the highest and the second highest Imports(as % of merchandise exports) in 1964?
Ensure brevity in your answer.  0.02. What is the difference between the highest and the second highest Imports(as % of merchandise exports) in 1965?
Your response must be concise. 2.36. What is the difference between the highest and the lowest Imports(as % of merchandise exports) of 1962?
Offer a very short reply. 8.94. What is the difference between the highest and the lowest Imports(as % of merchandise exports) in 1963?
Offer a terse response. 11.63. What is the difference between the highest and the lowest Imports(as % of merchandise exports) of 1964?
Keep it short and to the point. 9.86. What is the difference between the highest and the lowest Imports(as % of merchandise exports) of 1965?
Keep it short and to the point. 9.72. 